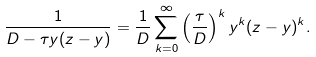Convert formula to latex. <formula><loc_0><loc_0><loc_500><loc_500>\frac { 1 } { D - \tau y ( z - y ) } = \frac { 1 } { D } \sum _ { k = 0 } ^ { \infty } \left ( \frac { \tau } { D } \right ) ^ { k } y ^ { k } ( z - y ) ^ { k } .</formula> 